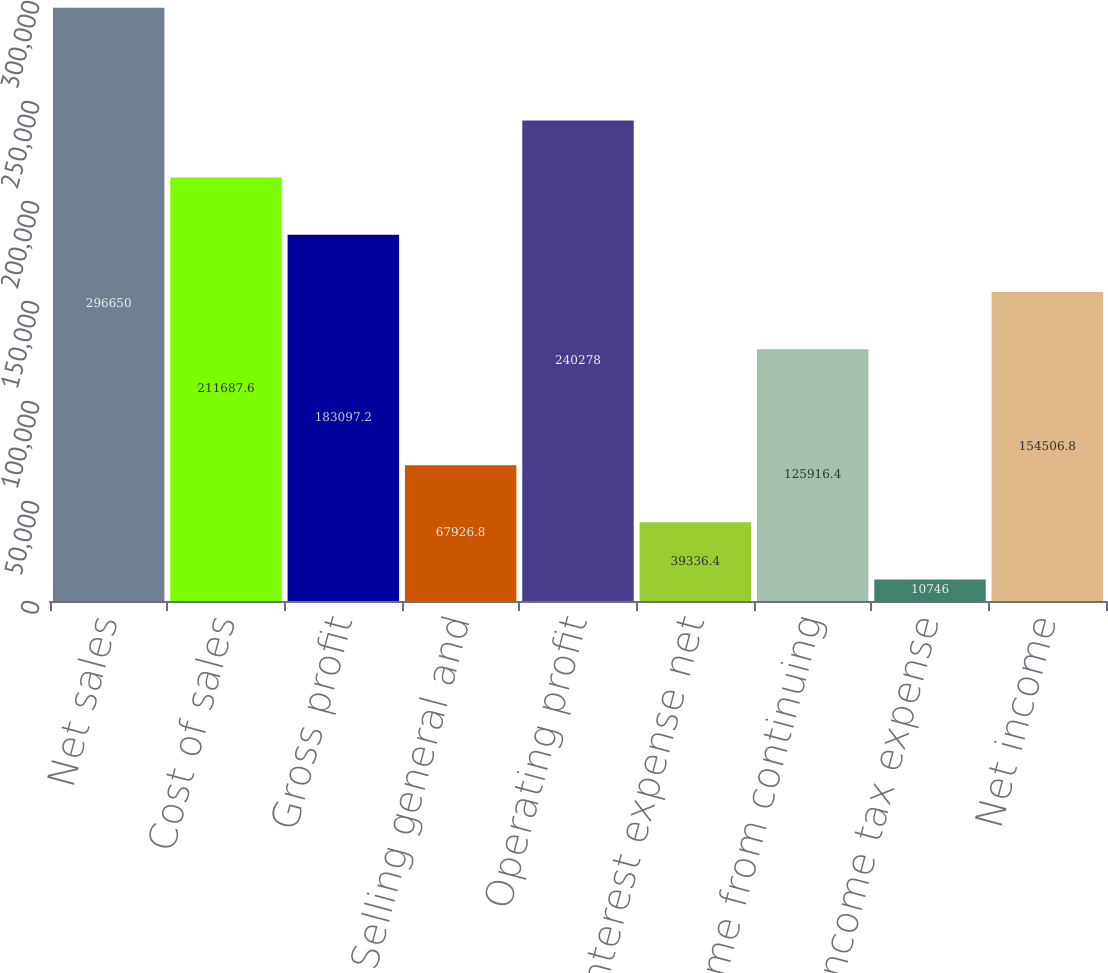<chart> <loc_0><loc_0><loc_500><loc_500><bar_chart><fcel>Net sales<fcel>Cost of sales<fcel>Gross profit<fcel>Selling general and<fcel>Operating profit<fcel>Interest expense net<fcel>Income from continuing<fcel>Income tax expense<fcel>Net income<nl><fcel>296650<fcel>211688<fcel>183097<fcel>67926.8<fcel>240278<fcel>39336.4<fcel>125916<fcel>10746<fcel>154507<nl></chart> 